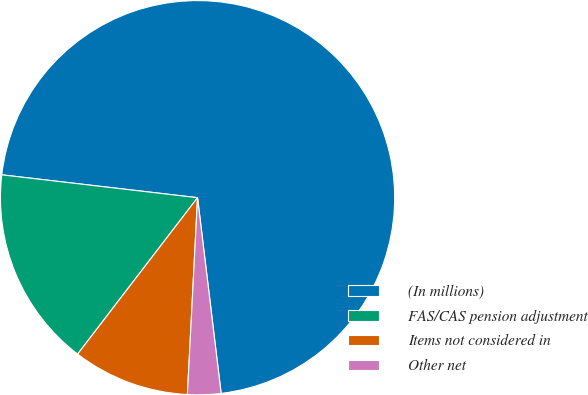Convert chart to OTSL. <chart><loc_0><loc_0><loc_500><loc_500><pie_chart><fcel>(In millions)<fcel>FAS/CAS pension adjustment<fcel>Items not considered in<fcel>Other net<nl><fcel>71.24%<fcel>16.44%<fcel>9.59%<fcel>2.73%<nl></chart> 